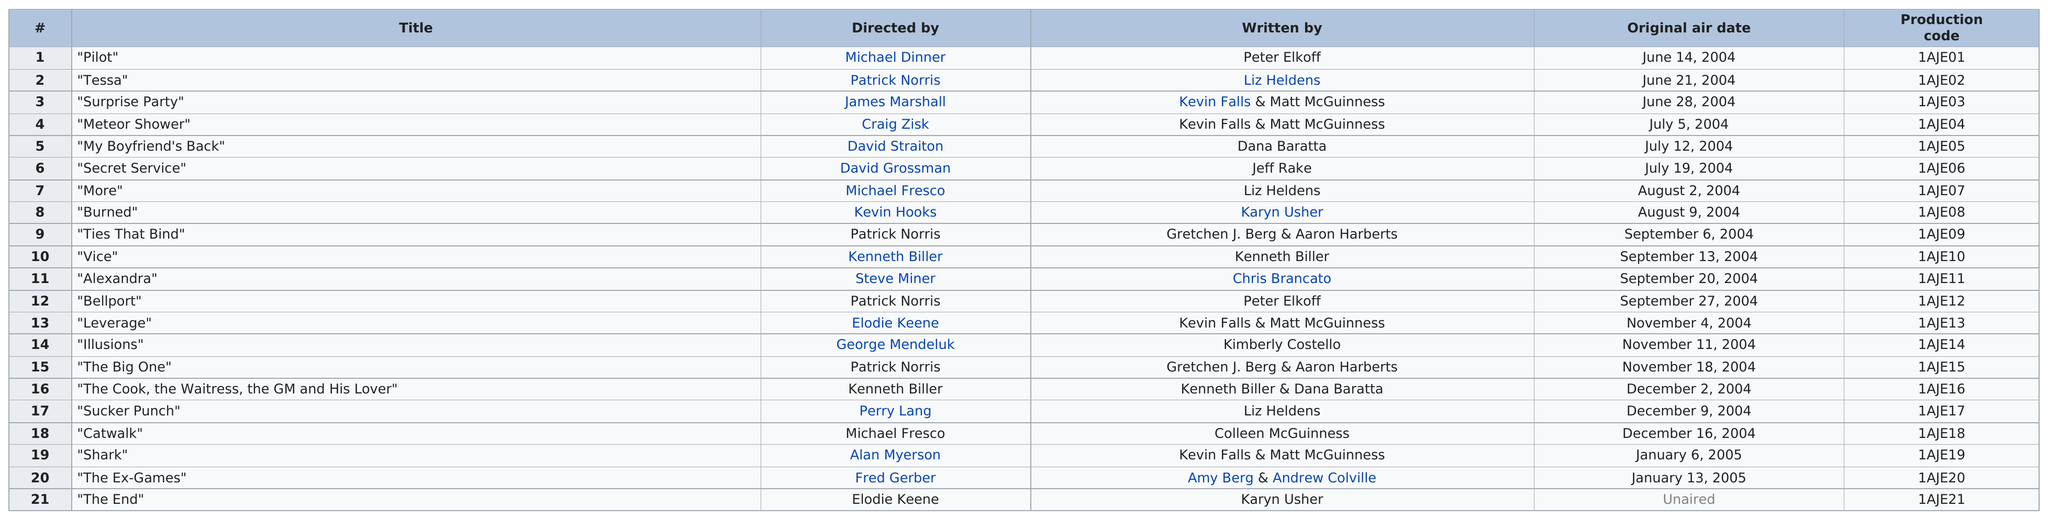Give some essential details in this illustration. Patrick Norris is the director who has the most titles accredited to them. In 2004, there were 18 titles. 